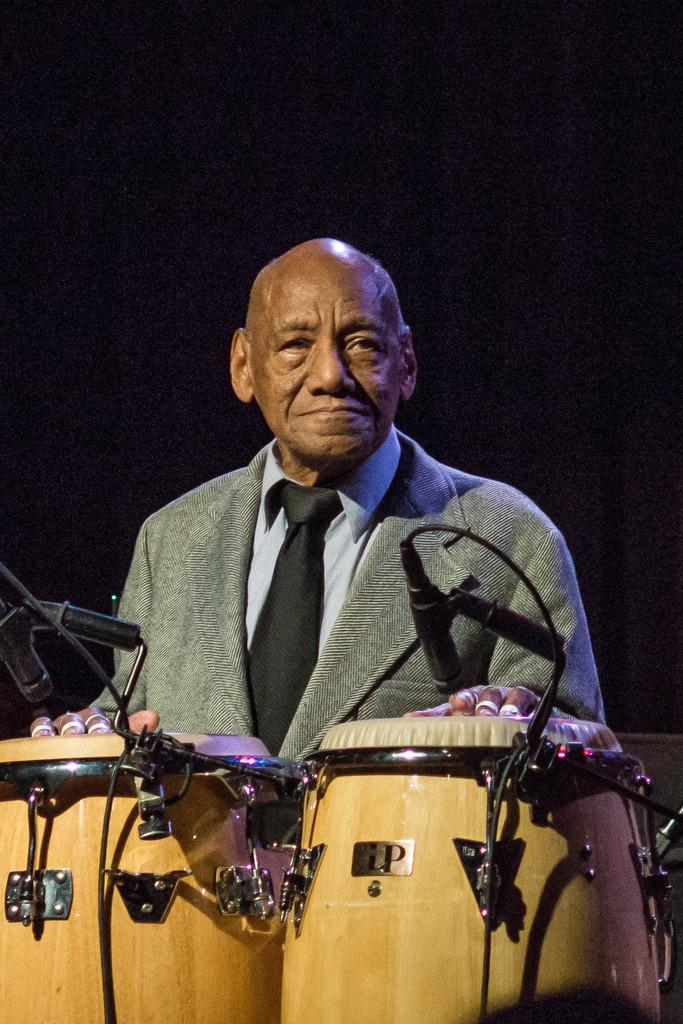Who is present in the image? There is a man in the image. What is the man wearing? The man is wearing a suit and tie. What is the man doing in the image? The man is standing. What musical instruments are in the image? There are musical drums in the image. What equipment is present for amplifying sound? There is a microphone with a mic holder in the image. What day of the week is it in the image? The day of the week cannot be determined from the image, as it only shows a man, his attire, and some musical instruments and equipment. 